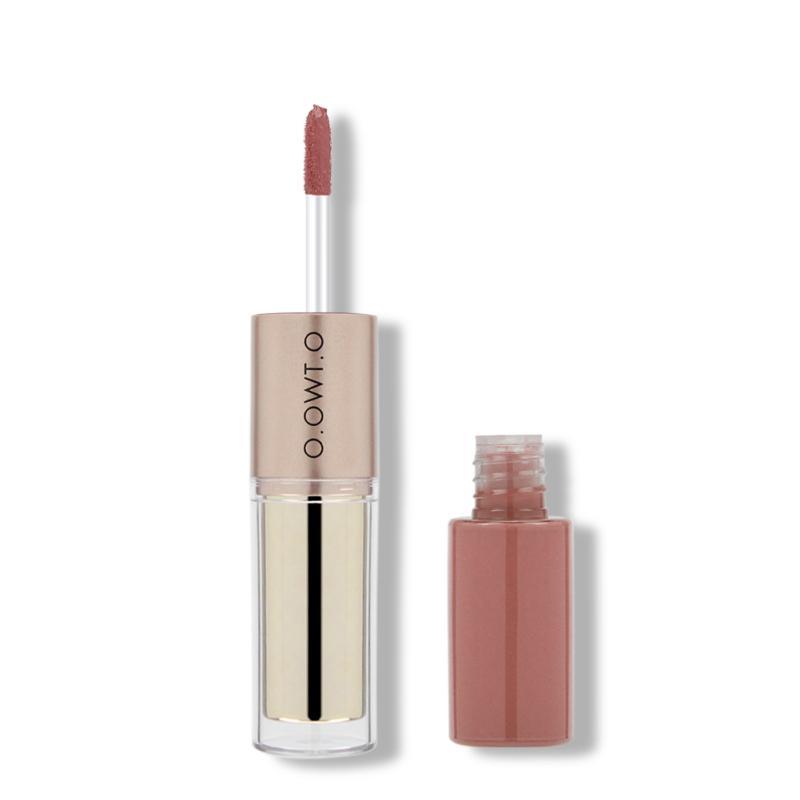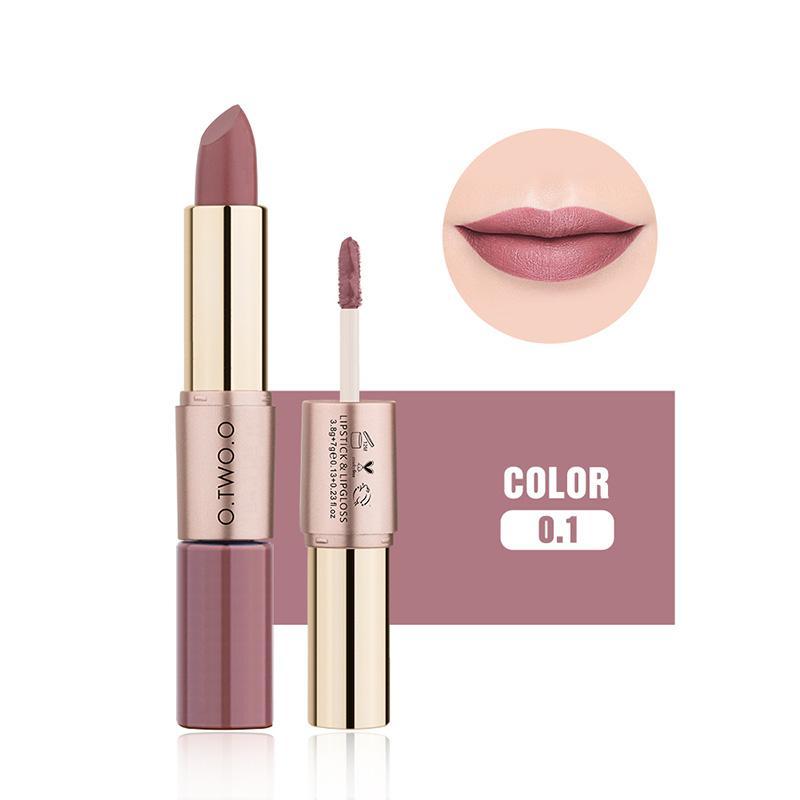The first image is the image on the left, the second image is the image on the right. Given the left and right images, does the statement "All of the products are exactly vertical." hold true? Answer yes or no. Yes. The first image is the image on the left, the second image is the image on the right. Assess this claim about the two images: "Fewer than four lip products are displayed.". Correct or not? Answer yes or no. Yes. 